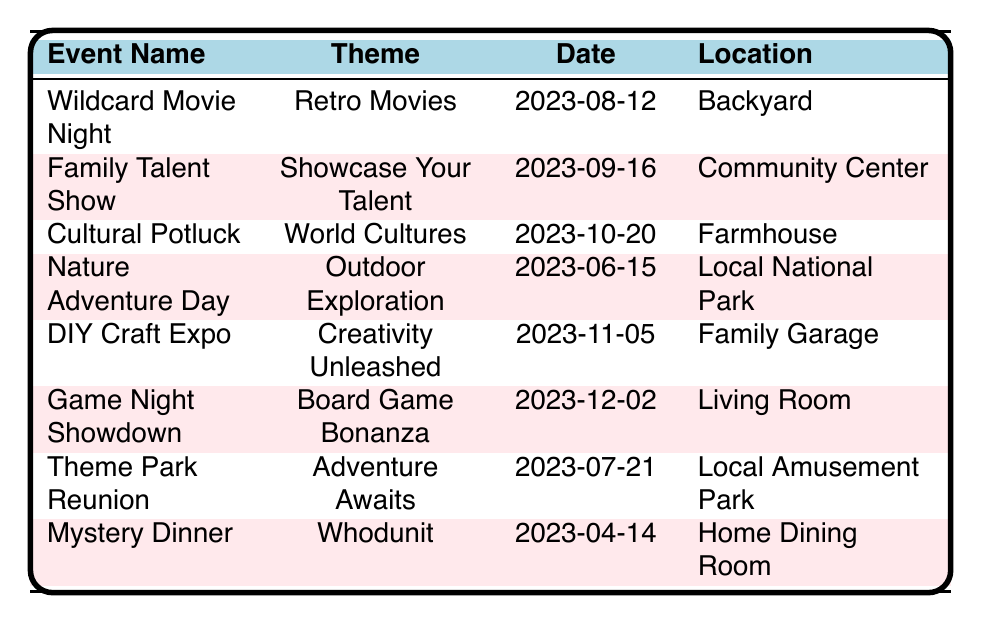What's the theme of the "Family Talent Show"? The theme for the "Family Talent Show" is listed directly in the table under the "Theme" column as "Showcase Your Talent."
Answer: Showcase Your Talent Which event is scheduled for October 20, 2023? The table shows that the event scheduled for October 20, 2023, is the "Cultural Potluck."
Answer: Cultural Potluck How many events are held in a backyard? By examining the "Location" column, only one event, "Wildcard Movie Night," is in the backyard, which can be counted directly.
Answer: 1 What is the difference between the number of participants in the "DIY Craft Expo" and the "Theme Park Reunion"? The "DIY Craft Expo" has 2 participants (Kids, Parents) and the "Theme Park Reunion" has 2 participants (Family, Friends), so the difference is 2 - 2 = 0.
Answer: 0 Is there an event with a theme related to outdoor activities? Yes, "Nature Adventure Day" has the theme "Outdoor Exploration," indicating it focuses on outdoor activities.
Answer: Yes Which two events have food items related to desserts? The "Cultural Potluck" features "Cultural Desserts" and the "Mystery Dinner" has "Themed Desserts," indicating both have dessert items listed in their food section.
Answer: Cultural Potluck, Mystery Dinner What is the earliest date for an event in the table? By reviewing the dates, the earliest event is "Mystery Dinner" on April 14, 2023.
Answer: April 14, 2023 How many unique themes are there in total across all events? The unique themes are: Retro Movies, Showcase Your Talent, World Cultures, Outdoor Exploration, Creativity Unleashed, Board Game Bonanza, Adventure Awaits, and Whodunit, totaling 8 unique themes.
Answer: 8 Which event includes activities such as "Costume Contest" and "Trivia Quiz"? The activities listed under "Wildcard Movie Night" include "Costume Contest" and "Trivia Quiz."
Answer: Wildcard Movie Night On which date does the "Game Night Showdown" take place, and what is its theme? The "Game Night Showdown" takes place on December 2, 2023, and its theme is "Board Game Bonanza."
Answer: December 2, 2023; Board Game Bonanza How many events take place in a location that is not a family home? "Wildcard Movie Night," "Family Talent Show," "Cultural Potluck," "Nature Adventure Day," "DIY Craft Expo," and "Theme Park Reunion" take place in locations other than home, totaling 6 events.
Answer: 6 